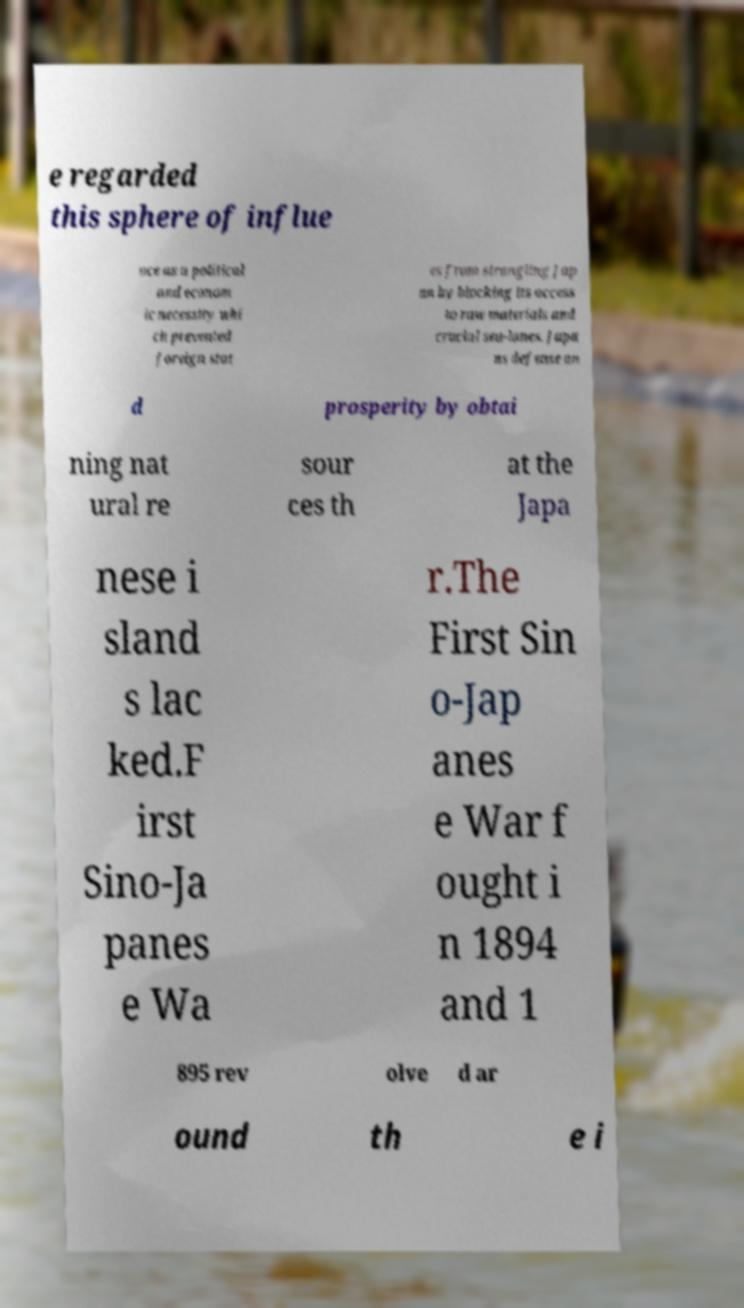What messages or text are displayed in this image? I need them in a readable, typed format. e regarded this sphere of influe nce as a political and econom ic necessity whi ch prevented foreign stat es from strangling Jap an by blocking its access to raw materials and crucial sea-lanes. Japa ns defense an d prosperity by obtai ning nat ural re sour ces th at the Japa nese i sland s lac ked.F irst Sino-Ja panes e Wa r.The First Sin o-Jap anes e War f ought i n 1894 and 1 895 rev olve d ar ound th e i 